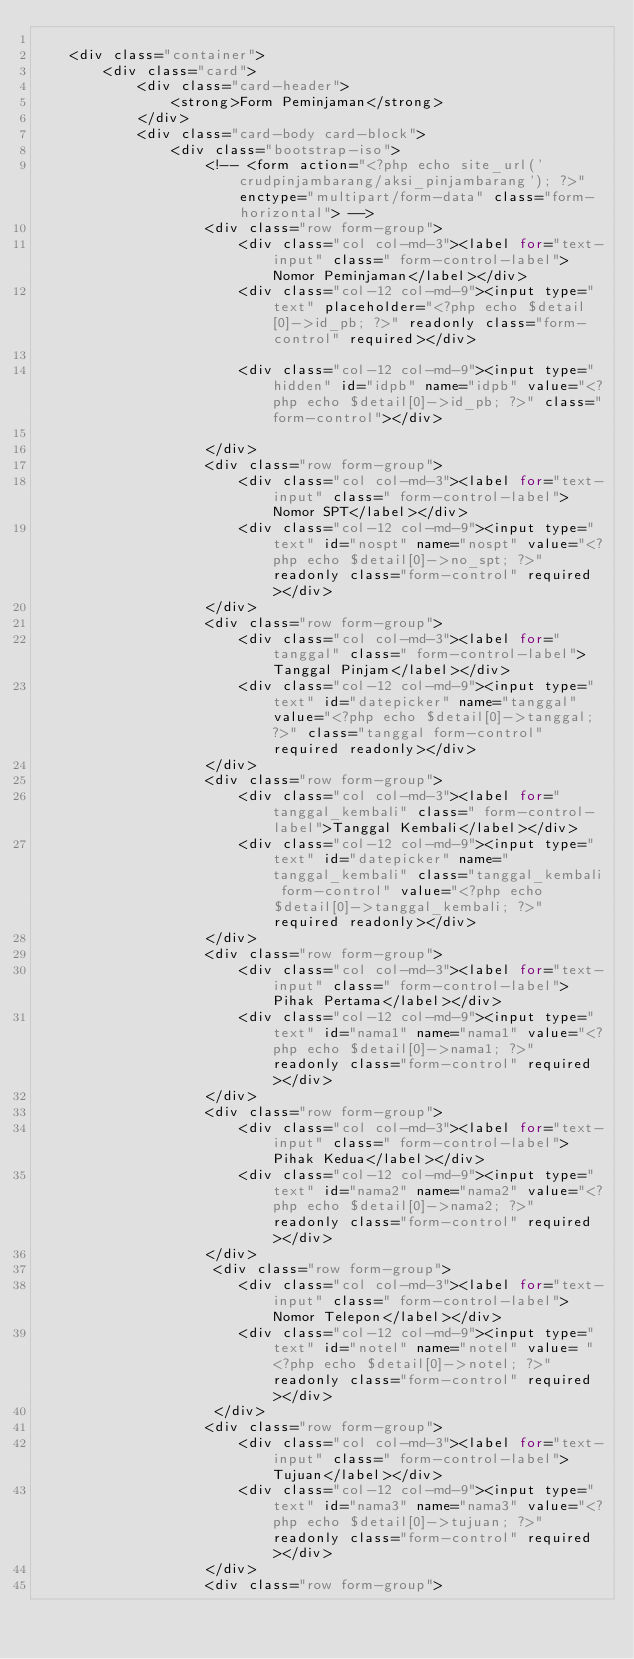Convert code to text. <code><loc_0><loc_0><loc_500><loc_500><_PHP_>
    <div class="container">
        <div class="card">
            <div class="card-header">
                <strong>Form Peminjaman</strong>
            </div>
            <div class="card-body card-block">
                <div class="bootstrap-iso">
                    <!-- <form action="<?php echo site_url('crudpinjambarang/aksi_pinjambarang'); ?>" enctype="multipart/form-data" class="form-horizontal"> -->
                    <div class="row form-group">
                        <div class="col col-md-3"><label for="text-input" class=" form-control-label">Nomor Peminjaman</label></div>
                        <div class="col-12 col-md-9"><input type="text" placeholder="<?php echo $detail[0]->id_pb; ?>" readonly class="form-control" required></div>

                        <div class="col-12 col-md-9"><input type="hidden" id="idpb" name="idpb" value="<?php echo $detail[0]->id_pb; ?>" class="form-control"></div>

                    </div>
                    <div class="row form-group">
                        <div class="col col-md-3"><label for="text-input" class=" form-control-label">Nomor SPT</label></div>
                        <div class="col-12 col-md-9"><input type="text" id="nospt" name="nospt" value="<?php echo $detail[0]->no_spt; ?>" readonly class="form-control" required></div>
                    </div>
                    <div class="row form-group">
                        <div class="col col-md-3"><label for="tanggal" class=" form-control-label">Tanggal Pinjam</label></div>
                        <div class="col-12 col-md-9"><input type="text" id="datepicker" name="tanggal" value="<?php echo $detail[0]->tanggal; ?>" class="tanggal form-control" required readonly></div>
                    </div>
                    <div class="row form-group">
                        <div class="col col-md-3"><label for="tanggal_kembali" class=" form-control-label">Tanggal Kembali</label></div>
                        <div class="col-12 col-md-9"><input type="text" id="datepicker" name="tanggal_kembali" class="tanggal_kembali form-control" value="<?php echo $detail[0]->tanggal_kembali; ?>" required readonly></div>
                    </div>
                    <div class="row form-group">
                        <div class="col col-md-3"><label for="text-input" class=" form-control-label">Pihak Pertama</label></div>
                        <div class="col-12 col-md-9"><input type="text" id="nama1" name="nama1" value="<?php echo $detail[0]->nama1; ?>" readonly class="form-control" required></div>
                    </div>
                    <div class="row form-group">
                        <div class="col col-md-3"><label for="text-input" class=" form-control-label">Pihak Kedua</label></div>
                        <div class="col-12 col-md-9"><input type="text" id="nama2" name="nama2" value="<?php echo $detail[0]->nama2; ?>" readonly class="form-control" required></div>
                    </div>
                     <div class="row form-group">
                        <div class="col col-md-3"><label for="text-input" class=" form-control-label">Nomor Telepon</label></div>
                        <div class="col-12 col-md-9"><input type="text" id="notel" name="notel" value= "<?php echo $detail[0]->notel; ?>" readonly class="form-control" required></div>
                     </div>
                    <div class="row form-group">
                        <div class="col col-md-3"><label for="text-input" class=" form-control-label">Tujuan</label></div>
                        <div class="col-12 col-md-9"><input type="text" id="nama3" name="nama3" value="<?php echo $detail[0]->tujuan; ?>" readonly class="form-control" required></div>
                    </div>
                    <div class="row form-group"></code> 